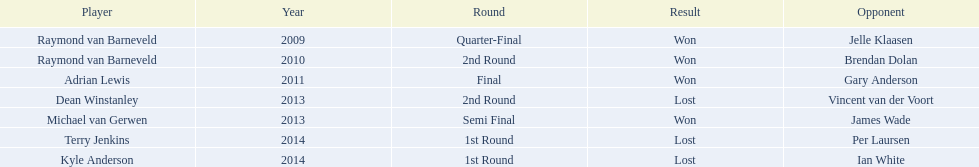Who are the participants? Raymond van Barneveld, Raymond van Barneveld, Adrian Lewis, Dean Winstanley, Michael van Gerwen, Terry Jenkins, Kyle Anderson. When did they participate? 2009, 2010, 2011, 2013, 2013, 2014, 2014. And, which participant was active in 2011? Adrian Lewis. 